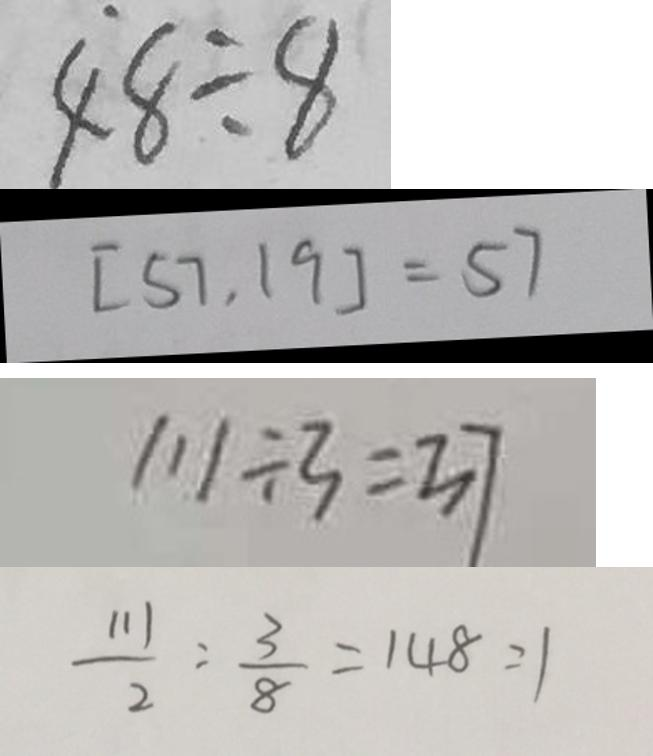<formula> <loc_0><loc_0><loc_500><loc_500>4 8 \div 8 
 [ 5 7 , 1 9 ] = 5 7 
 1 1 1 \div 3 = 3 7 
 \frac { 1 1 1 } { 2 } : \frac { 3 } { 8 } = 1 4 8 : 1</formula> 